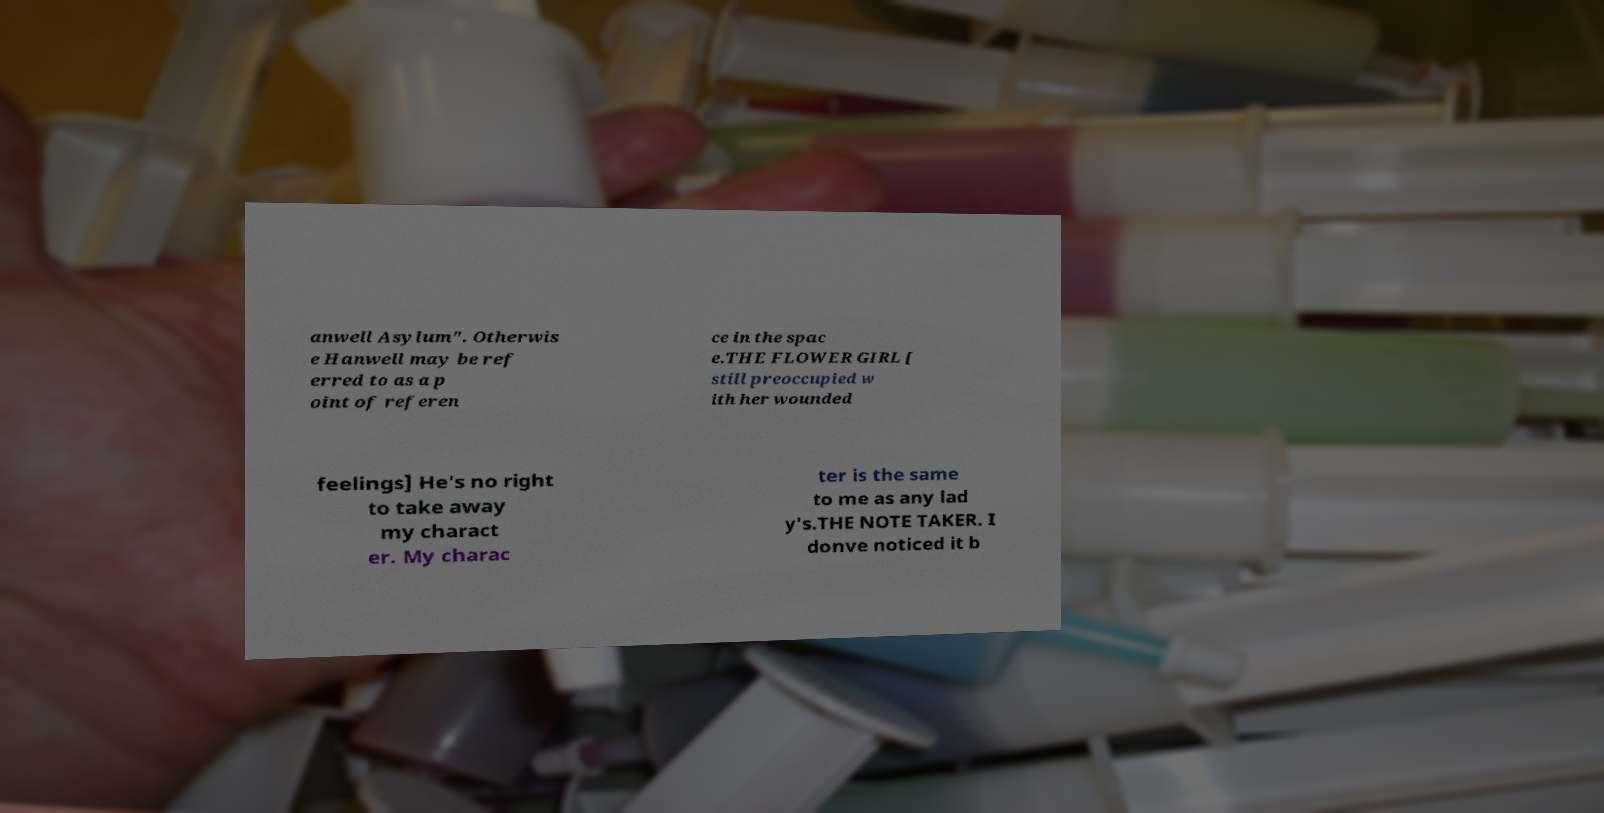What messages or text are displayed in this image? I need them in a readable, typed format. anwell Asylum". Otherwis e Hanwell may be ref erred to as a p oint of referen ce in the spac e.THE FLOWER GIRL [ still preoccupied w ith her wounded feelings] He's no right to take away my charact er. My charac ter is the same to me as any lad y's.THE NOTE TAKER. I donve noticed it b 